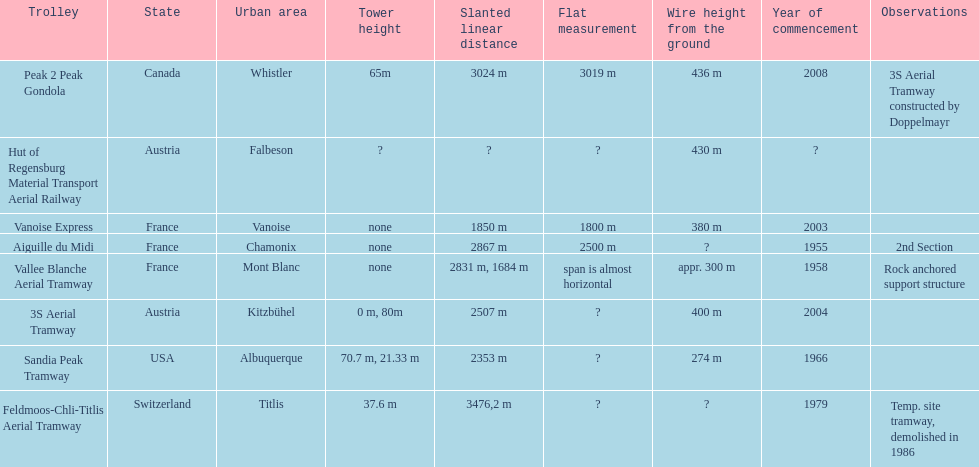How much longer is the peak 2 peak gondola than the 32 aerial tramway? 517. 